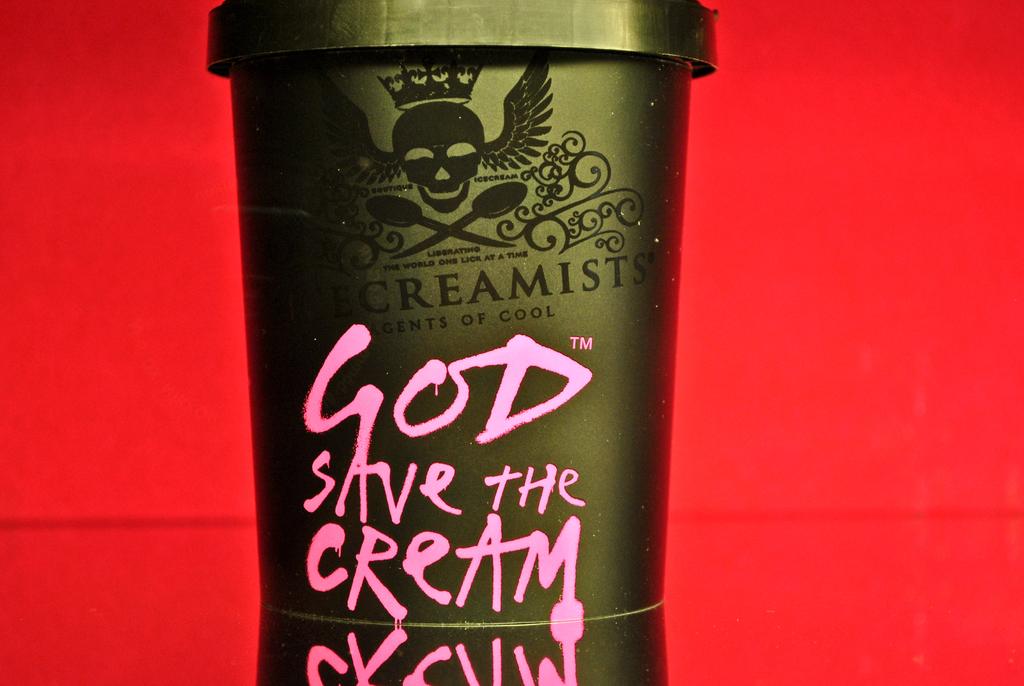What is the name of this ice cream?
Offer a terse response. God save the cream. 